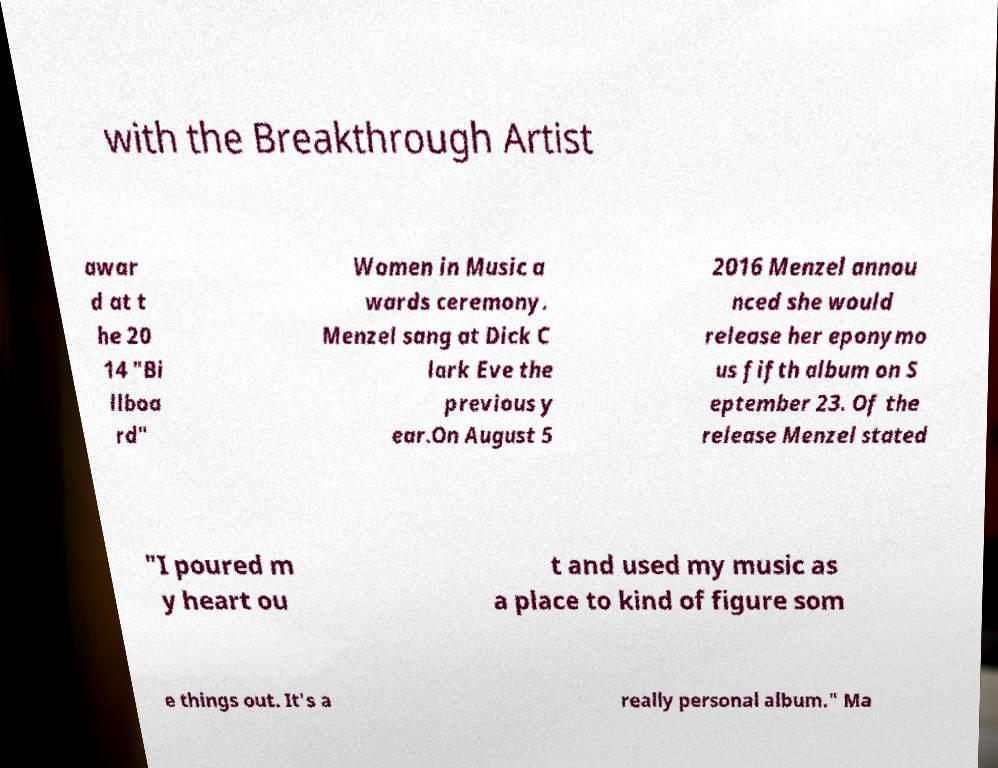Can you read and provide the text displayed in the image?This photo seems to have some interesting text. Can you extract and type it out for me? with the Breakthrough Artist awar d at t he 20 14 "Bi llboa rd" Women in Music a wards ceremony. Menzel sang at Dick C lark Eve the previous y ear.On August 5 2016 Menzel annou nced she would release her eponymo us fifth album on S eptember 23. Of the release Menzel stated "I poured m y heart ou t and used my music as a place to kind of figure som e things out. It's a really personal album." Ma 